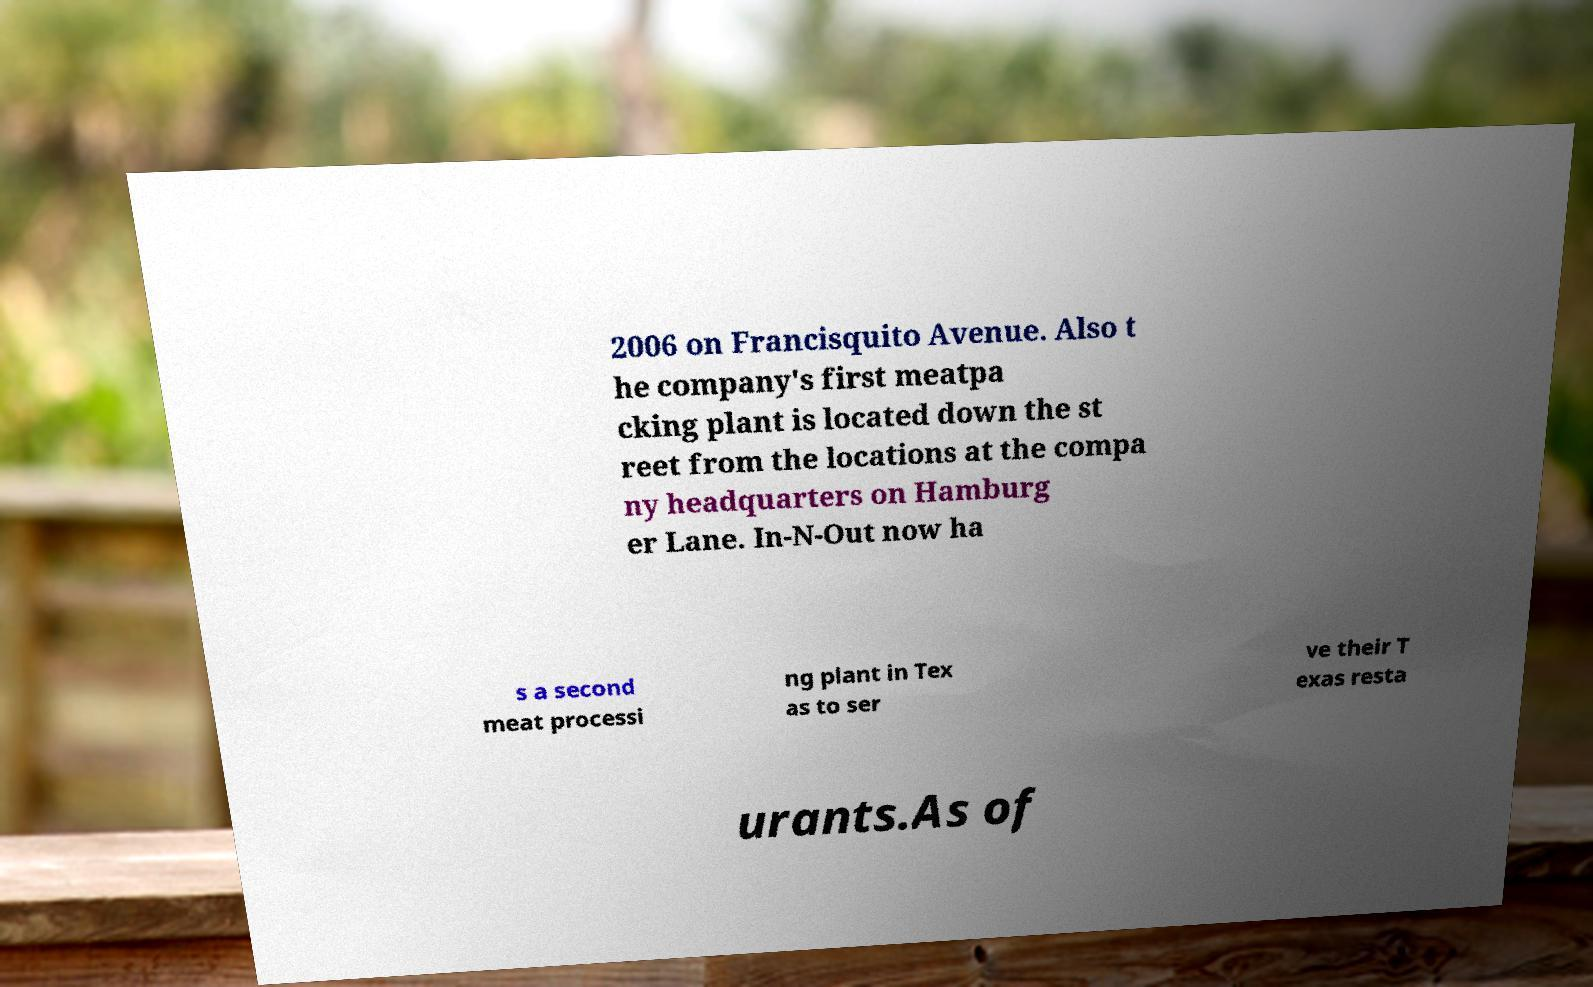There's text embedded in this image that I need extracted. Can you transcribe it verbatim? 2006 on Francisquito Avenue. Also t he company's first meatpa cking plant is located down the st reet from the locations at the compa ny headquarters on Hamburg er Lane. In-N-Out now ha s a second meat processi ng plant in Tex as to ser ve their T exas resta urants.As of 